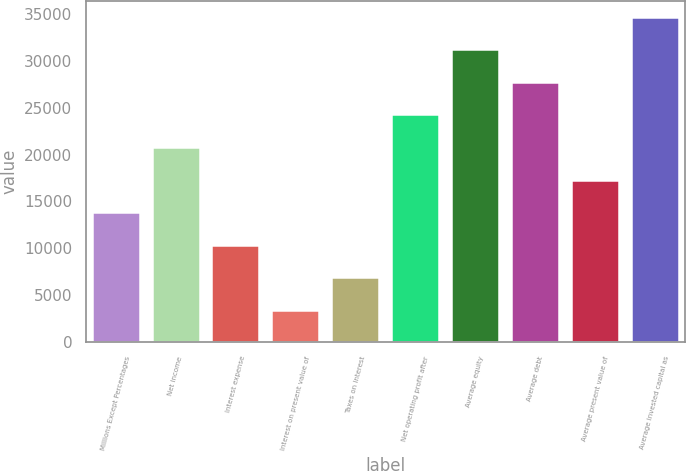<chart> <loc_0><loc_0><loc_500><loc_500><bar_chart><fcel>Millions Except Percentages<fcel>Net income<fcel>Interest expense<fcel>Interest on present value of<fcel>Taxes on interest<fcel>Net operating profit after<fcel>Average equity<fcel>Average debt<fcel>Average present value of<fcel>Average invested capital as<nl><fcel>13872.1<fcel>20800.1<fcel>10408.1<fcel>3480.18<fcel>6944.16<fcel>24264.1<fcel>31192<fcel>27728<fcel>17336.1<fcel>34656<nl></chart> 